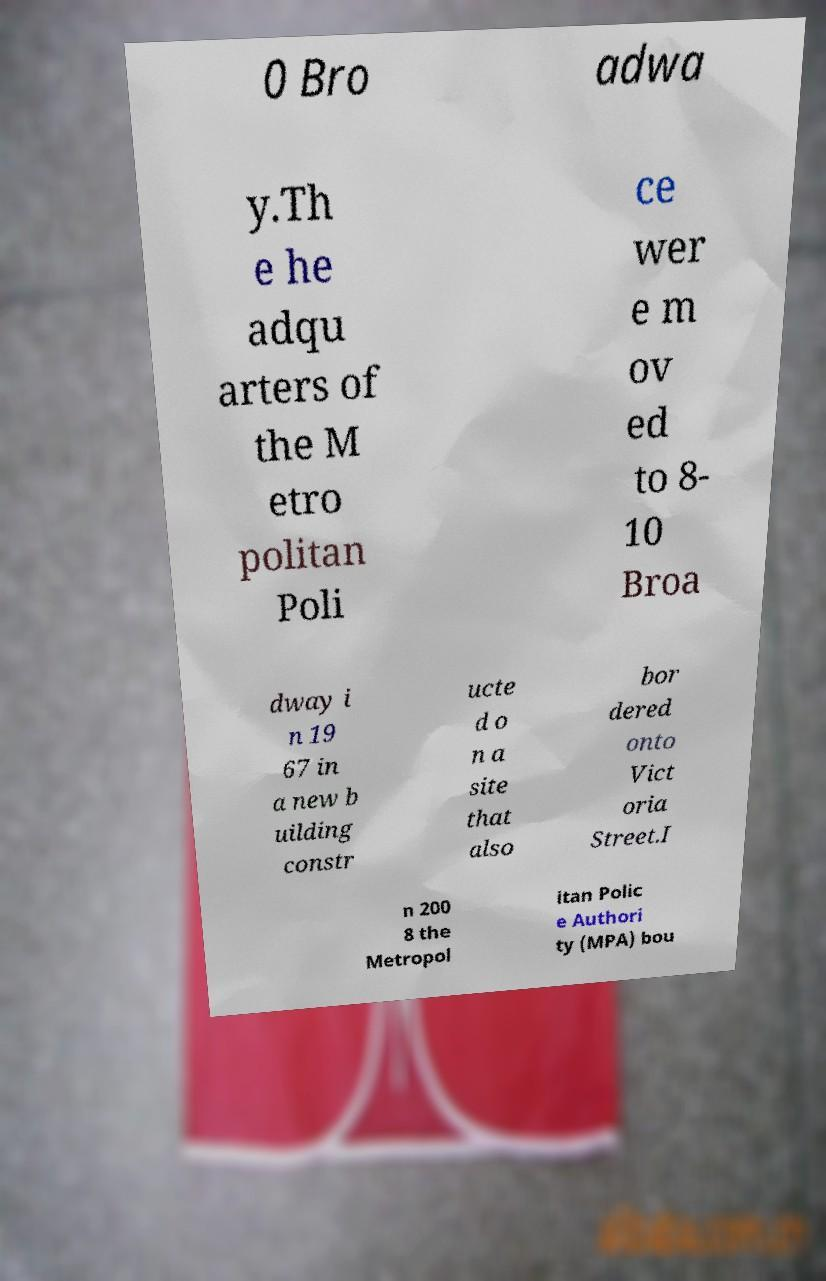Could you assist in decoding the text presented in this image and type it out clearly? 0 Bro adwa y.Th e he adqu arters of the M etro politan Poli ce wer e m ov ed to 8- 10 Broa dway i n 19 67 in a new b uilding constr ucte d o n a site that also bor dered onto Vict oria Street.I n 200 8 the Metropol itan Polic e Authori ty (MPA) bou 